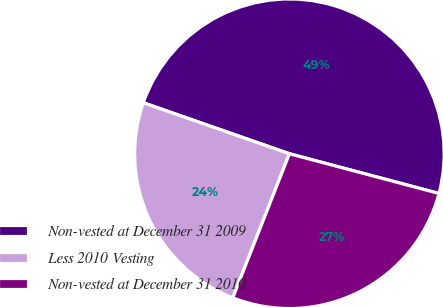Convert chart to OTSL. <chart><loc_0><loc_0><loc_500><loc_500><pie_chart><fcel>Non-vested at December 31 2009<fcel>Less 2010 Vesting<fcel>Non-vested at December 31 2010<nl><fcel>48.79%<fcel>24.39%<fcel>26.83%<nl></chart> 